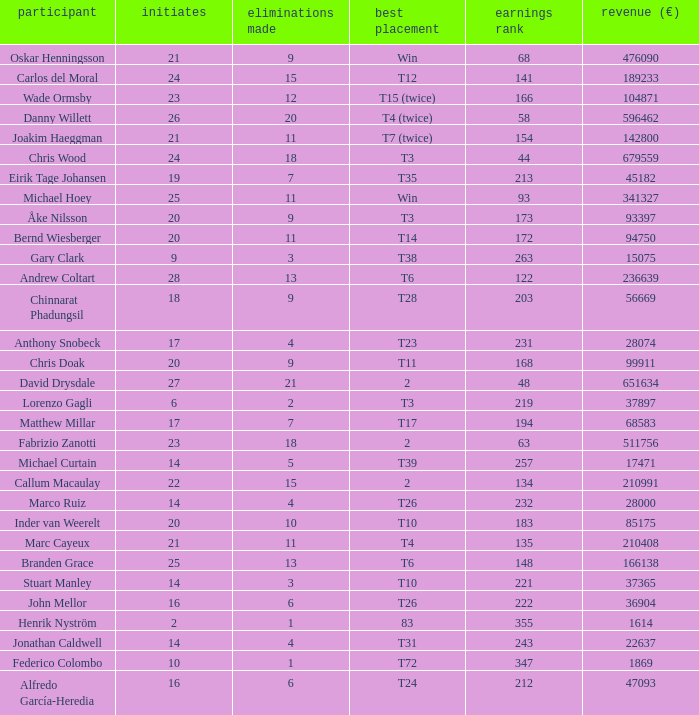How many cuts did the player who earned 210408 Euro make? 11.0. 